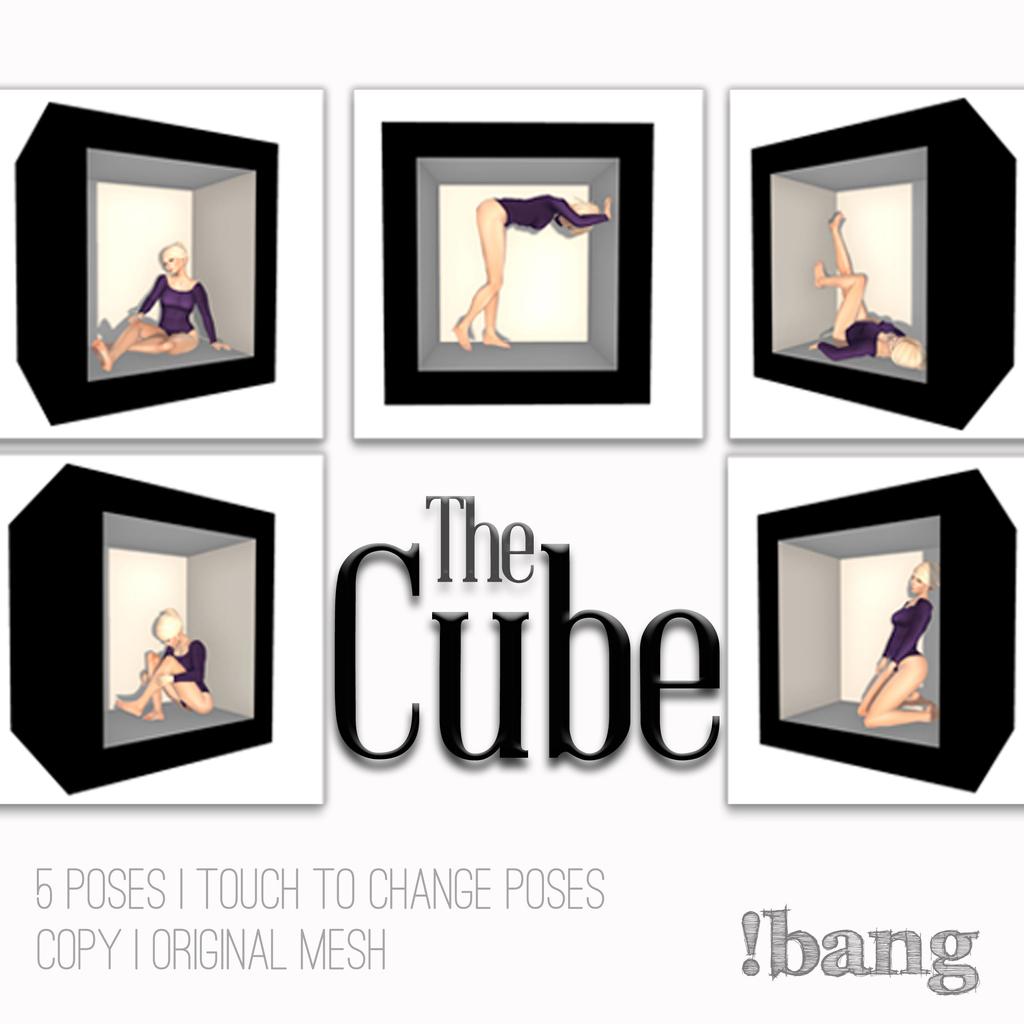How many poses?
Provide a succinct answer. 5. What is this called?
Your response must be concise. The cube. 